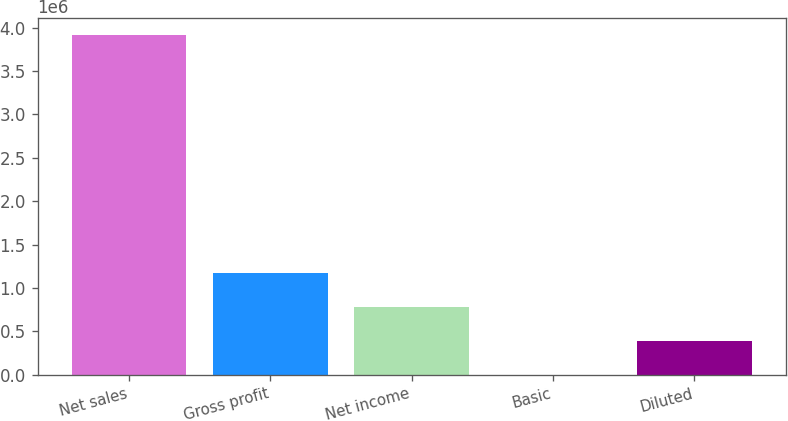<chart> <loc_0><loc_0><loc_500><loc_500><bar_chart><fcel>Net sales<fcel>Gross profit<fcel>Net income<fcel>Basic<fcel>Diluted<nl><fcel>3.9218e+06<fcel>1.17654e+06<fcel>784361<fcel>1.24<fcel>392181<nl></chart> 